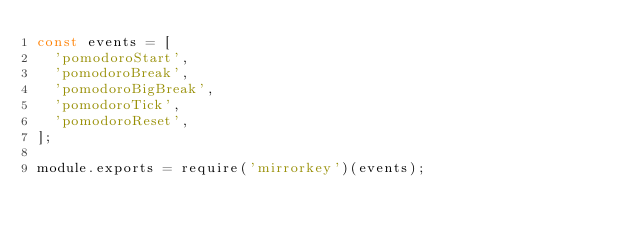Convert code to text. <code><loc_0><loc_0><loc_500><loc_500><_JavaScript_>const events = [
  'pomodoroStart',
  'pomodoroBreak',
  'pomodoroBigBreak',
  'pomodoroTick',
  'pomodoroReset',
];

module.exports = require('mirrorkey')(events);
</code> 